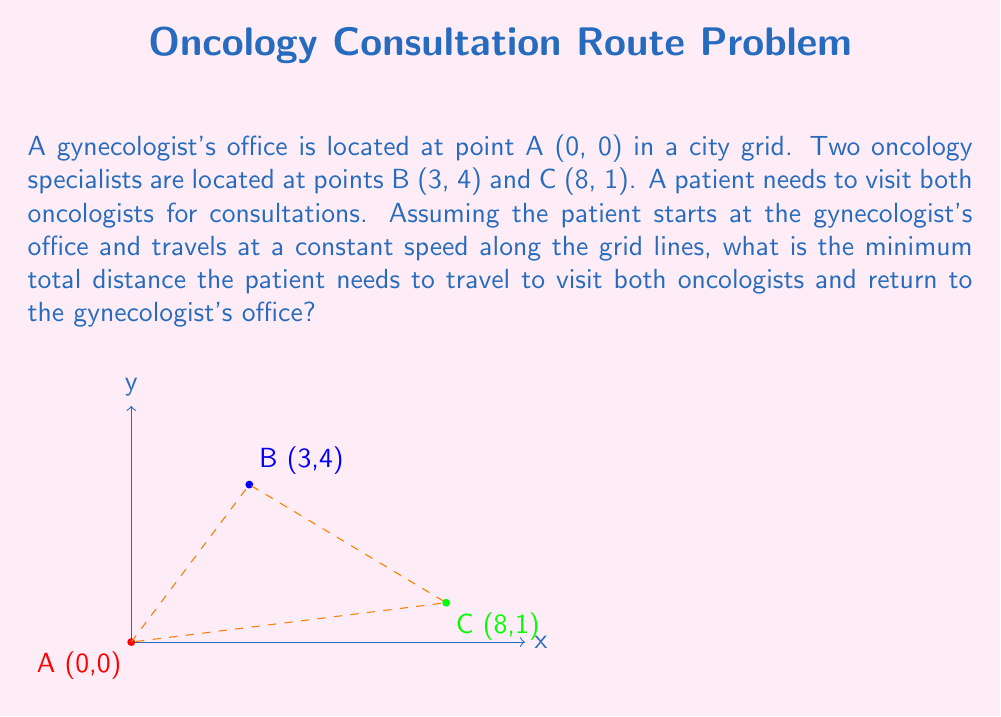Teach me how to tackle this problem. Let's approach this step-by-step:

1) First, we need to calculate the distances between each pair of points:

   Distance AB = $|3-0| + |4-0| = 3 + 4 = 7$
   Distance BC = $|8-3| + |1-4| = 5 + 3 = 8$
   Distance AC = $|8-0| + |1-0| = 8 + 1 = 9$

2) The problem is to find the shortest path that starts at A, visits both B and C, and returns to A. There are two possible routes:

   Route 1: A → B → C → A
   Route 2: A → C → B → A

3) Let's calculate the total distance for each route:

   Route 1: AB + BC + CA = 7 + 8 + 9 = 24
   Route 2: AC + CB + BA = 9 + 8 + 7 = 24

4) Both routes have the same total distance of 24 units.

5) Therefore, the minimum total distance the patient needs to travel is 24 units.

This problem is an example of the Traveling Salesman Problem, which becomes more complex with more points to visit. In this case, with only three points, we can solve it by simply comparing the two possible routes.
Answer: 24 units 